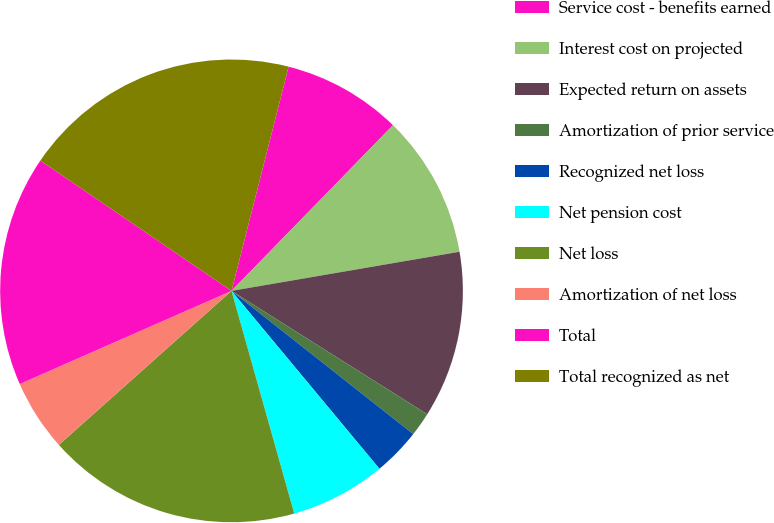<chart> <loc_0><loc_0><loc_500><loc_500><pie_chart><fcel>Service cost - benefits earned<fcel>Interest cost on projected<fcel>Expected return on assets<fcel>Amortization of prior service<fcel>Recognized net loss<fcel>Net pension cost<fcel>Net loss<fcel>Amortization of net loss<fcel>Total<fcel>Total recognized as net<nl><fcel>8.33%<fcel>10.0%<fcel>11.66%<fcel>1.67%<fcel>3.34%<fcel>6.67%<fcel>17.78%<fcel>5.0%<fcel>16.12%<fcel>19.45%<nl></chart> 